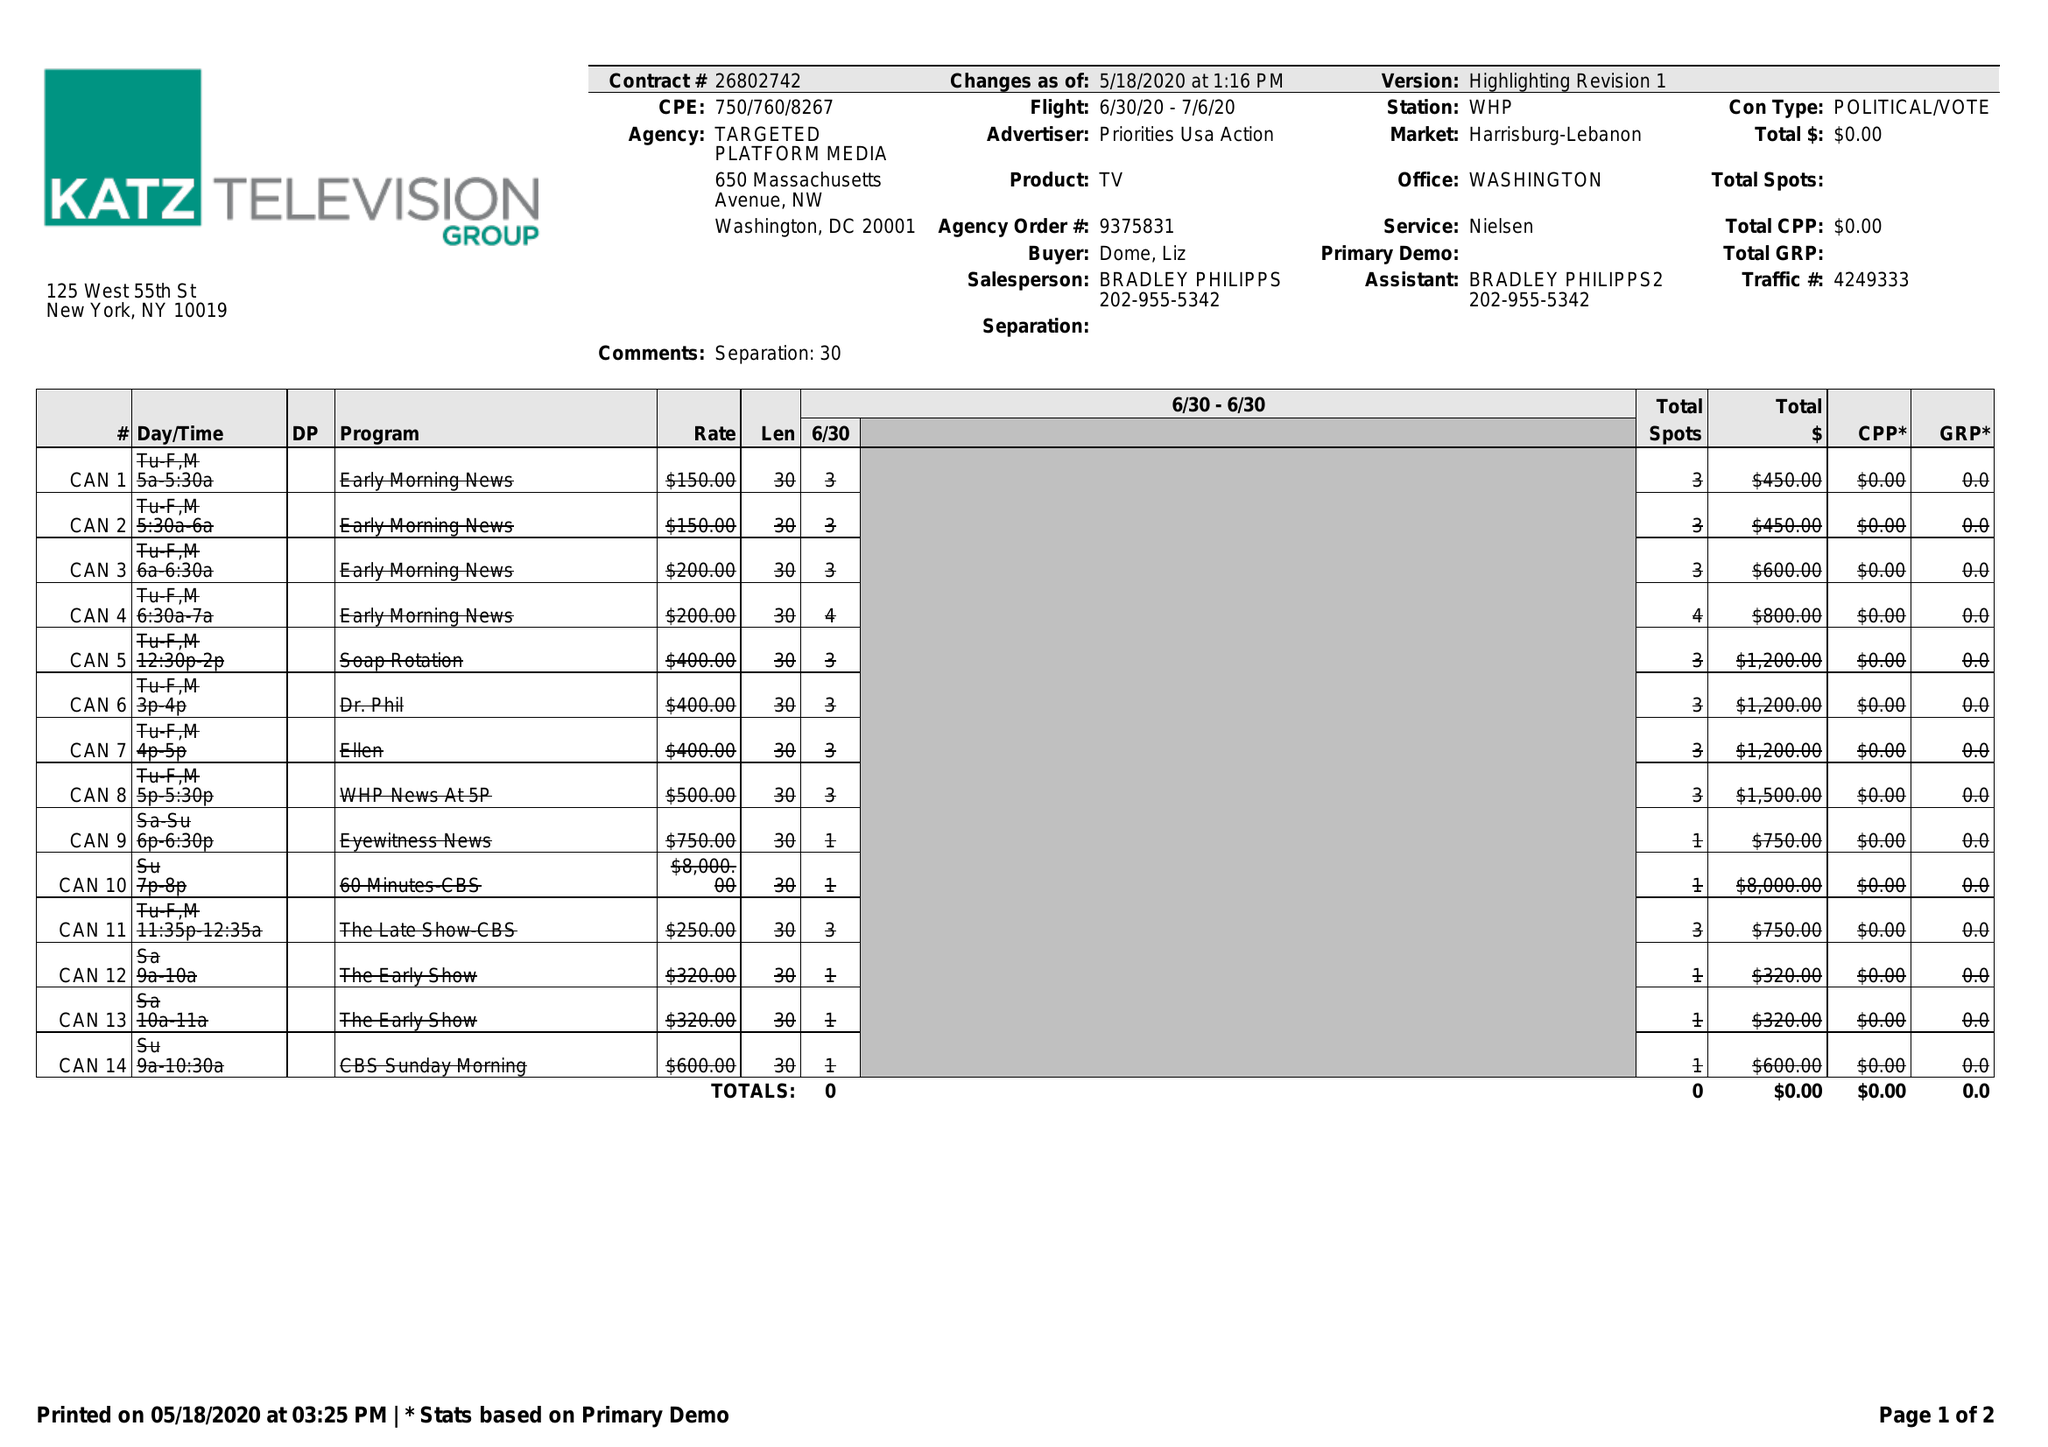What is the value for the gross_amount?
Answer the question using a single word or phrase. 0.00 